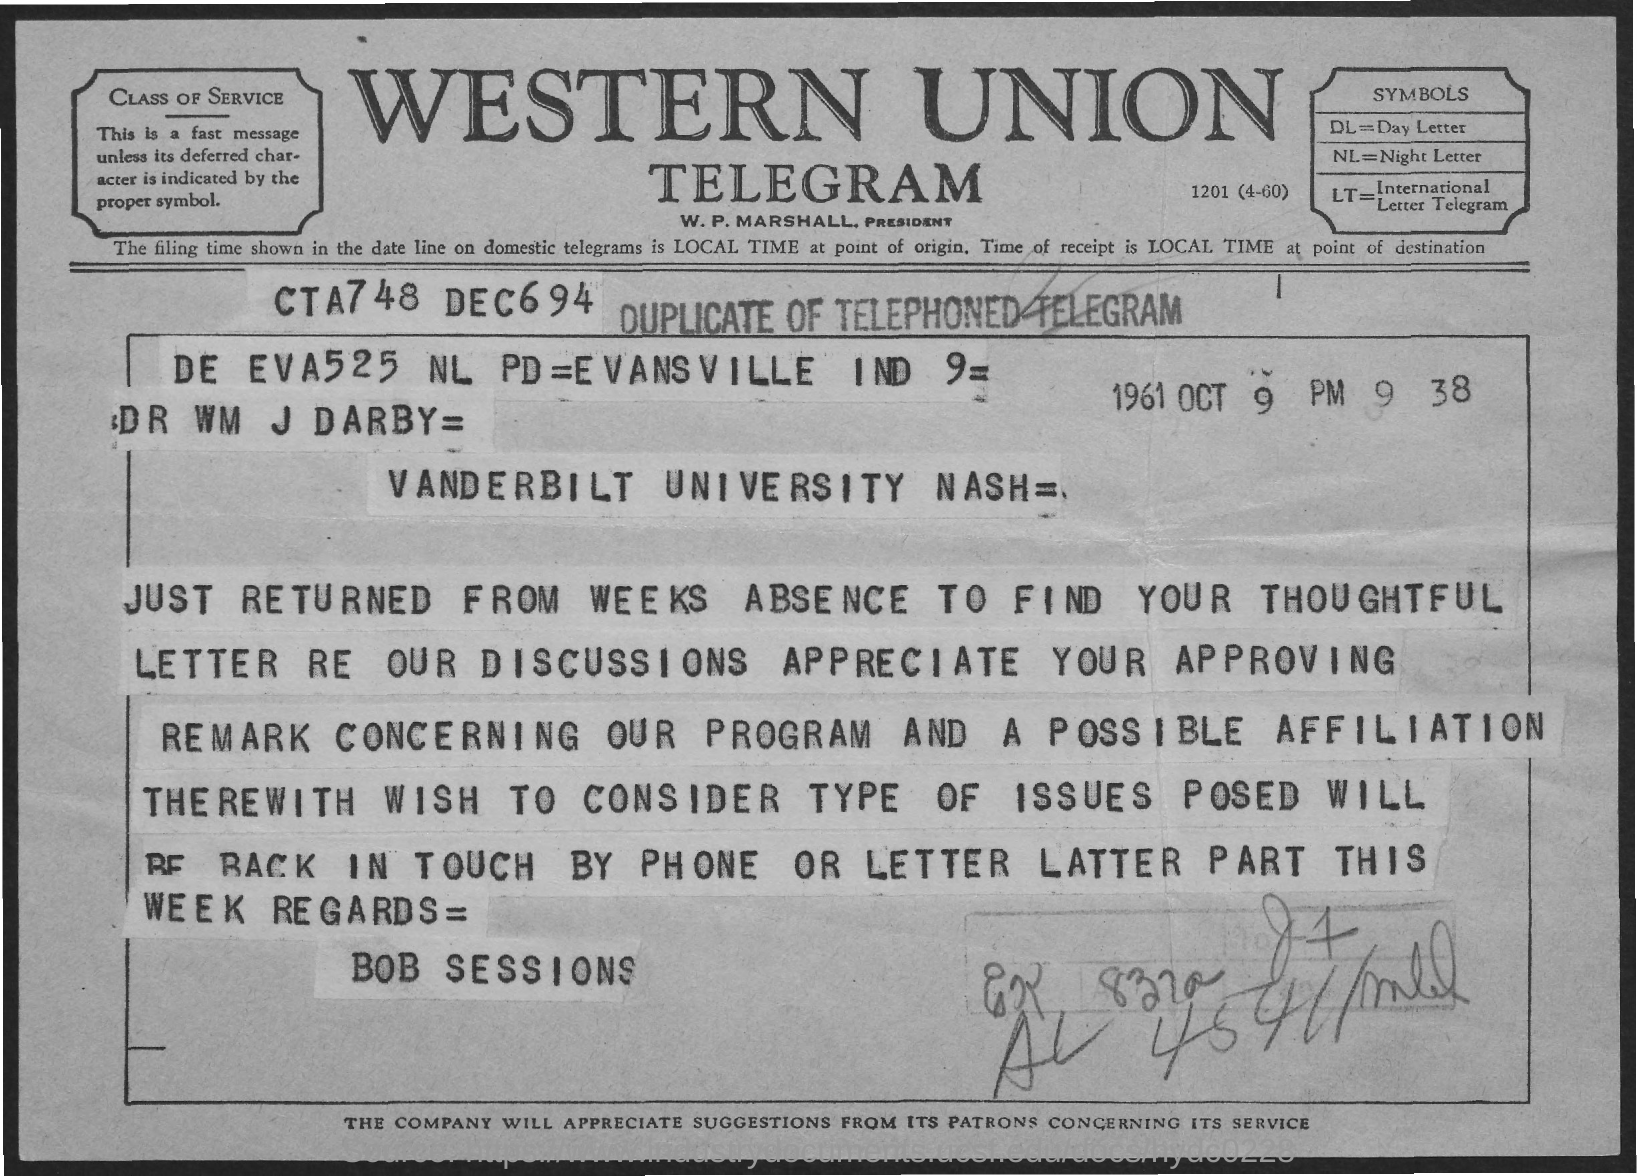Mention a couple of crucial points in this snapshot. The sender of this message on Telegram is Bob Sessions. 